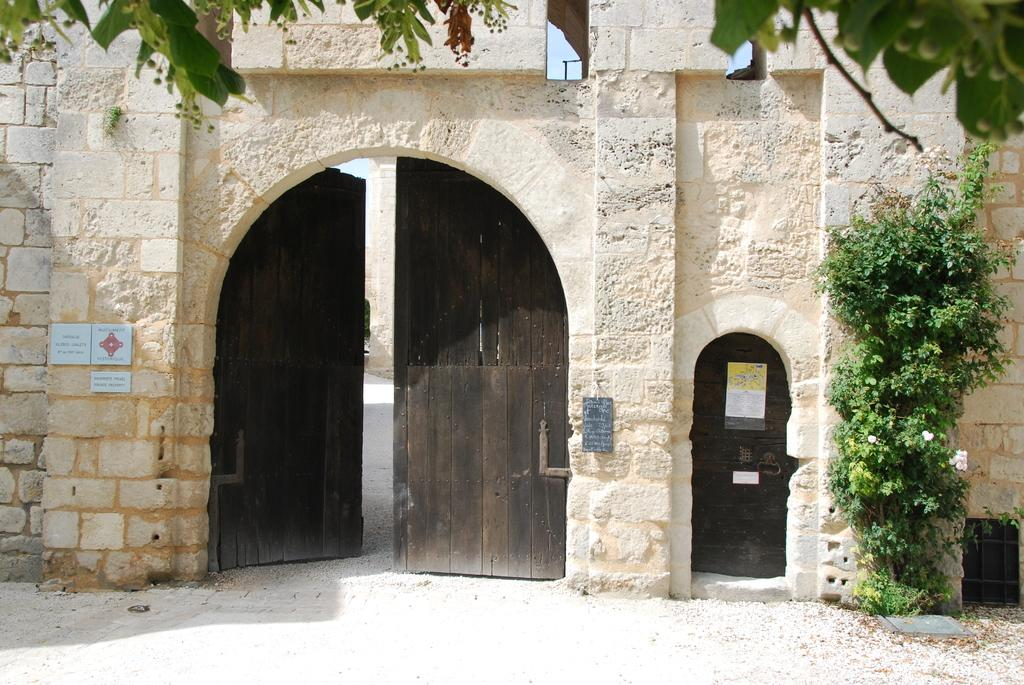What type of structure is shown in the image? There is a front view of a building in the image. What else can be seen in the image besides the building? There is a road and a plant visible in the image. Are there any openings in the building? Yes, there are doors in the image. How many balls are bouncing on the bridge in the image? There is no bridge or balls present in the image. What type of lock is securing the doors in the image? There is no lock visible in the image; only doors are mentioned. 